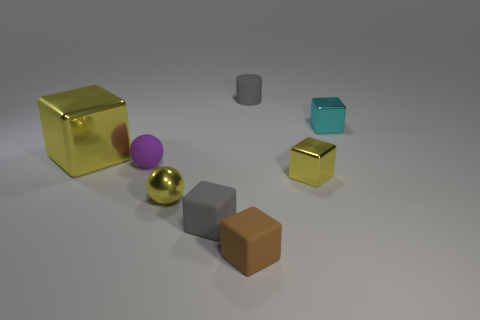Add 1 big green things. How many objects exist? 9 Subtract all brown blocks. How many blocks are left? 4 Subtract all tiny gray cubes. How many cubes are left? 4 Subtract all yellow blocks. Subtract all cyan cylinders. How many blocks are left? 3 Subtract all red spheres. How many brown blocks are left? 1 Subtract all cyan matte balls. Subtract all rubber blocks. How many objects are left? 6 Add 7 small gray cylinders. How many small gray cylinders are left? 8 Add 4 small cyan metal things. How many small cyan metal things exist? 5 Subtract 1 brown blocks. How many objects are left? 7 Subtract all cylinders. How many objects are left? 7 